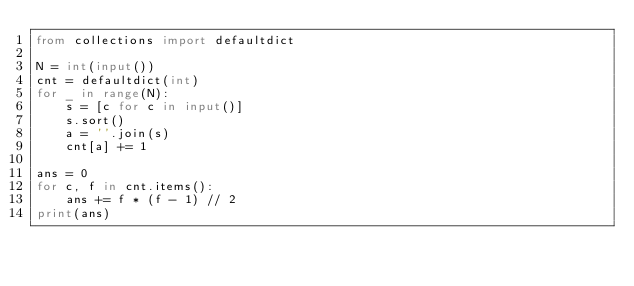Convert code to text. <code><loc_0><loc_0><loc_500><loc_500><_Python_>from collections import defaultdict

N = int(input())
cnt = defaultdict(int)
for _ in range(N):
    s = [c for c in input()]
    s.sort()
    a = ''.join(s)
    cnt[a] += 1

ans = 0
for c, f in cnt.items():
    ans += f * (f - 1) // 2
print(ans)</code> 